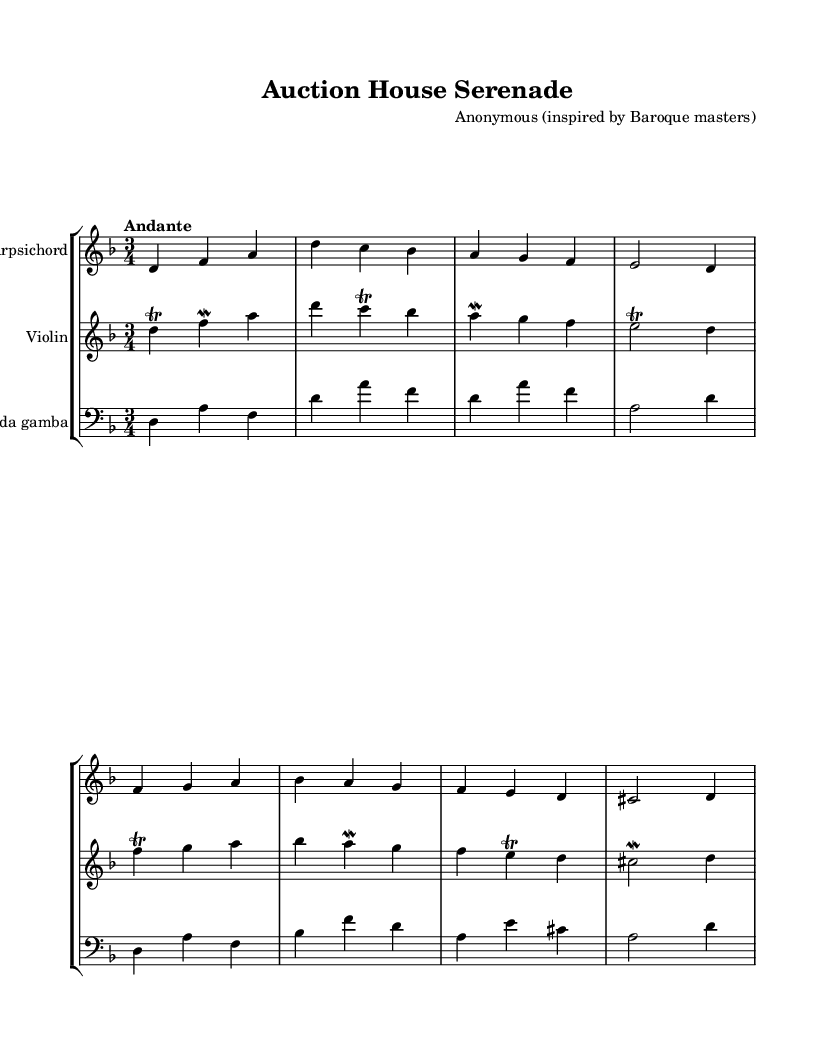What is the key signature of this music? The key signature is indicated by the number of sharps or flats at the beginning of the staff. In this score, there is one flat (B flat), indicating that the key is D minor.
Answer: D minor What is the time signature of this piece? The time signature is displayed at the beginning of the staff, indicating how the beats are organized in each measure. In this sheet music, the time signature shows a "3/4," which means there are three beats in each measure and a quarter note gets one beat.
Answer: 3/4 What is the tempo marking for this composition? The tempo marking is written in Italian above the staff. In this score, "Andante" is indicated, which describes a moderately slow tempo.
Answer: Andante How many measures are in the harpsichord part? To find the number of measures, count each group of notes separated by vertical lines (barlines) in the harpsichord part. Counting them reveals that there are 8 measures present.
Answer: 8 Which instruments are featured in this chamber music? The instruments can be identified by the staff groupings at the beginning of the sheet music. The visible staves indicate a harpsichord, violin, and viola da gamba, which show that these are the three instruments involved in the composition.
Answer: Harpsichord, Violin, Viola da gamba What is the interval between the first two notes in the violin part? The first two notes in the violin part are D and F. In music, the distance between these two notes can be measured in steps: D to E is one step, and E to F is another. Since there are two half steps from D to F, the interval is a minor third.
Answer: Minor third Is there a trill indicated in the violin's first measure? A trill is represented in the music by a special marking, usually written above the note. In the first measure, there is a trill sign above the note D, indicating that the player should quickly alternate between D and E, creating a decorative effect.
Answer: Yes 